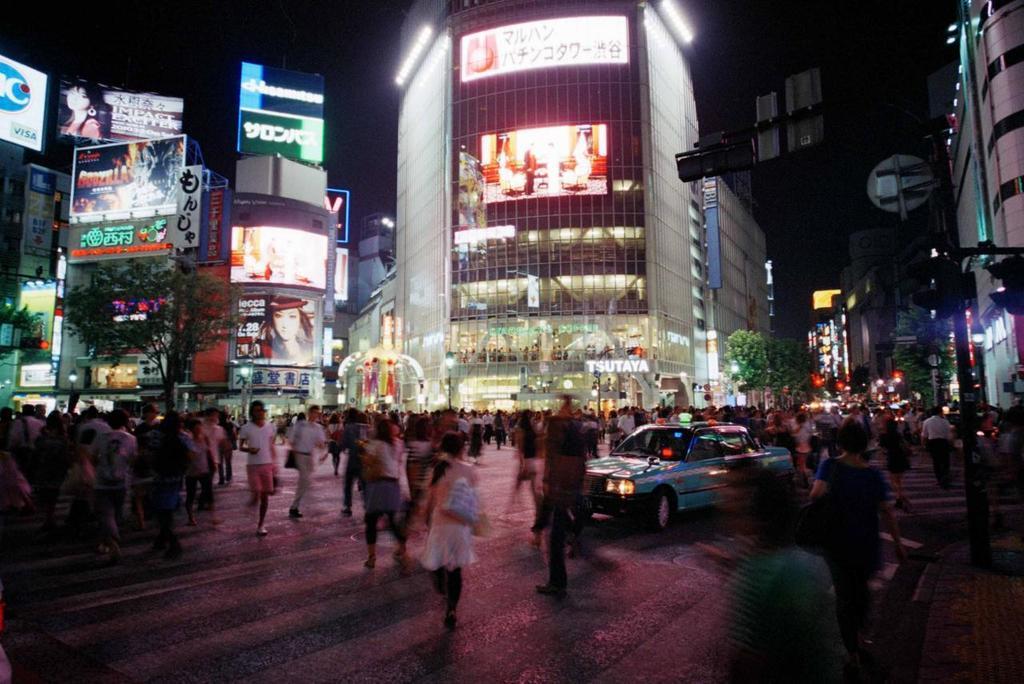How would you summarize this image in a sentence or two? In this image there are a few people walking on the streets of a city center and there is a car passing on the road, in the background of the image there are trees and billboards on the buildings. 